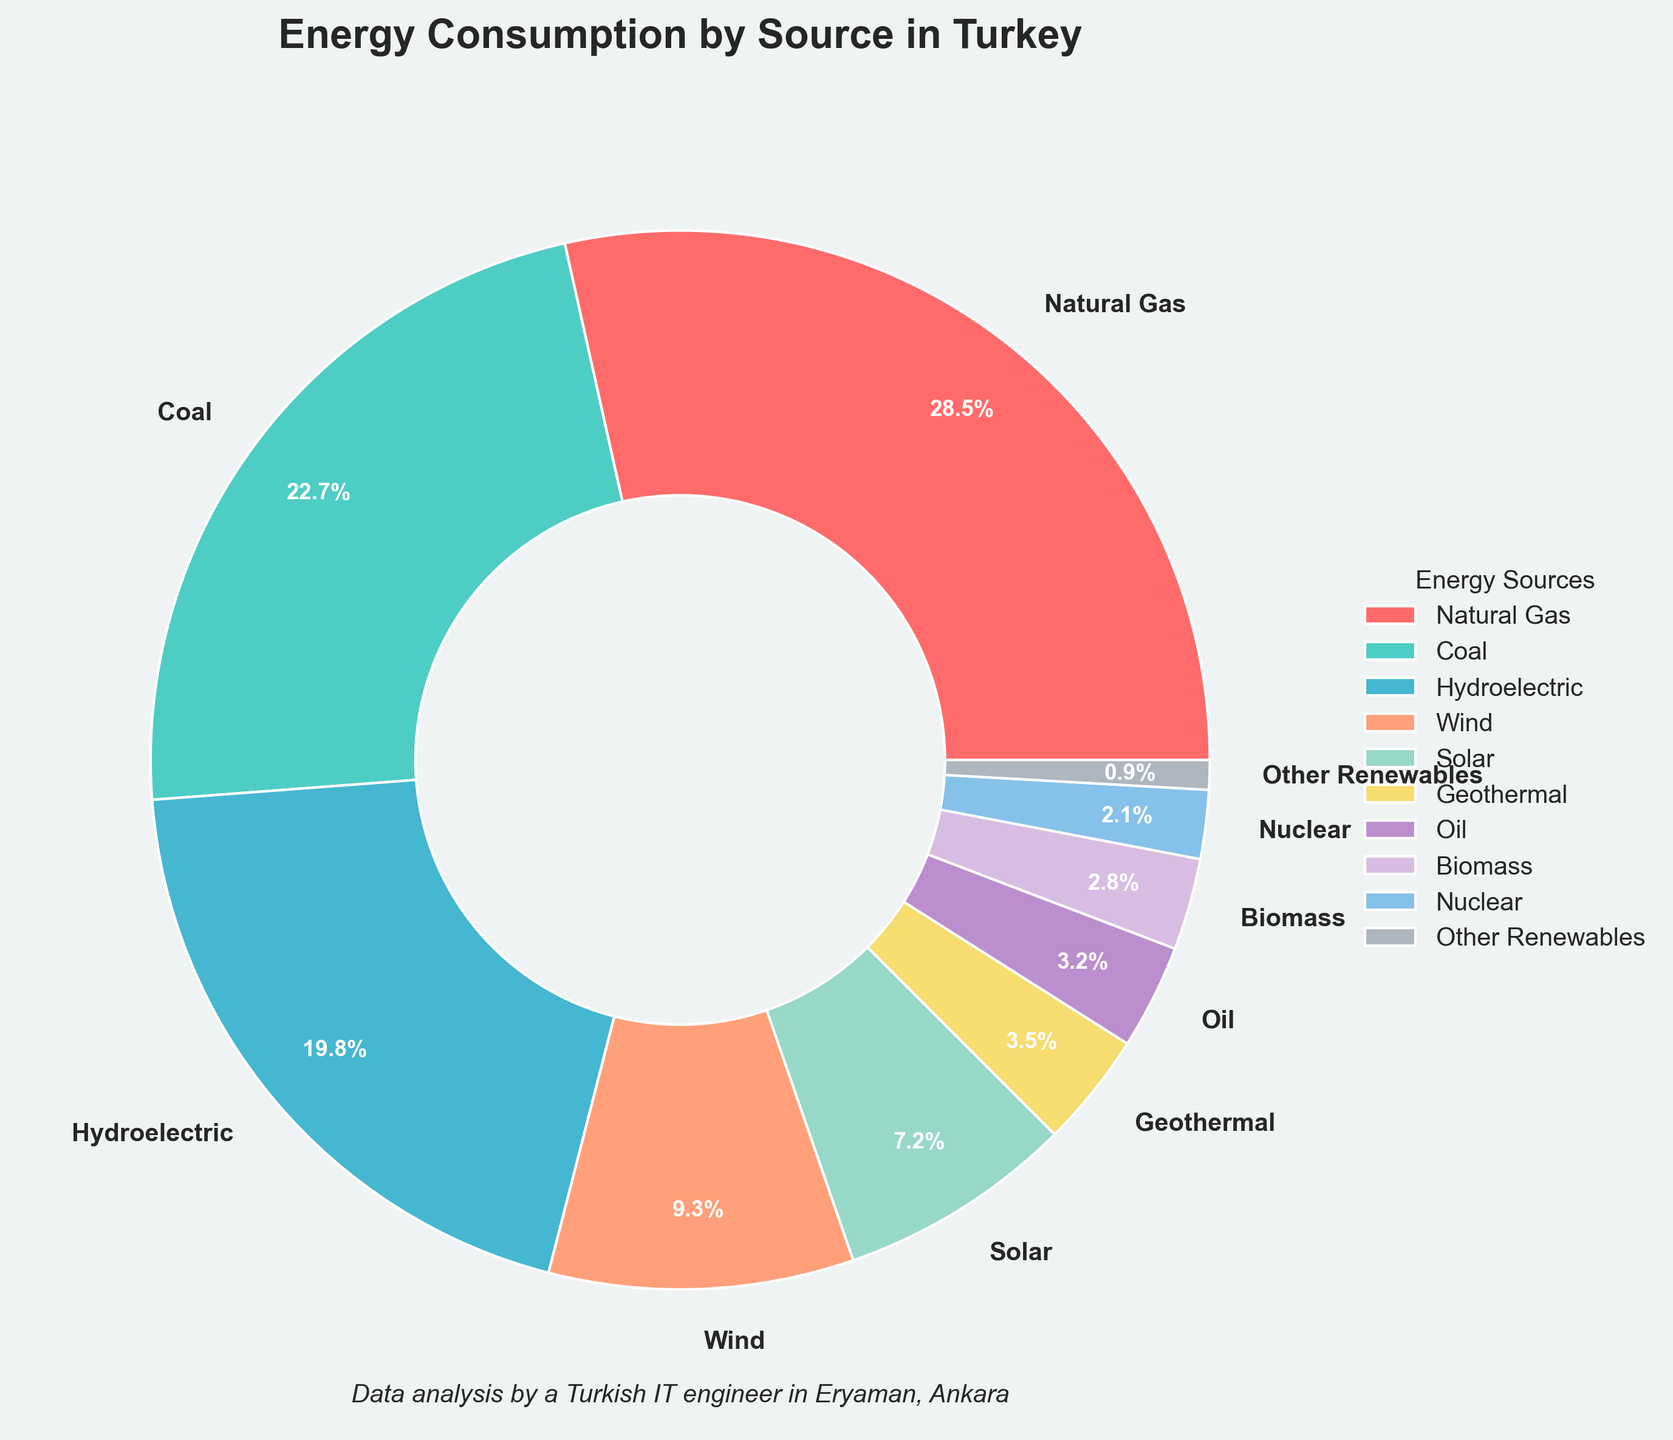What is the energy source with the highest consumption percentage? The pie chart shows the energy sources and their respective consumption percentages. The segment labeled "Natural Gas" has the highest percentage of 28.5%.
Answer: Natural Gas Which two energy sources have the closest consumption percentages, and what are they? By comparing the percentages, "Geothermal" (3.5%) and "Oil" (3.2%) are the closest with a difference of 0.3%.
Answer: Geothermal and Oil What is the total percentage of renewable energy sources (Hydroelectric, Wind, Solar, Geothermal, Biomass, Other Renewables)? Sum the percentages of renewable sources: Hydroelectric (19.8%), Wind (9.3%), Solar (7.2%), Geothermal (3.5%), Biomass (2.8%), Other Renewables (0.9%). The total is 19.8 + 9.3 + 7.2 + 3.5 + 2.8 + 0.9 = 43.5%.
Answer: 43.5% Which energy source contributes the least to energy consumption in Turkey? The smallest segment on the pie chart belongs to "Other Renewables" with 0.9%.
Answer: Other Renewables How much greater is the percentage of Natural Gas consumption compared to Coal consumption? Natural Gas consumption is 28.5% and Coal is 22.7%. Subtract Coal's percentage from Natural Gas’ percentage: 28.5% - 22.7% = 5.8%.
Answer: 5.8% What is the percentage difference between the highest and the lowest contributing energy sources? The highest contributing source is Natural Gas at 28.5% and the lowest is Other Renewables at 0.9%. Subtract the lowest from the highest: 28.5% - 0.9% = 27.6%.
Answer: 27.6% What is the combined percentage of Solar and Wind energy? Add the percentages for Solar (7.2%) and Wind (9.3%): 7.2% + 9.3% = 16.5%.
Answer: 16.5% Between Wind and Biomass, which one is consumed more and by what percentage? Wind has a higher percentage (9.3%) compared to Biomass (2.8%). The difference is 9.3% - 2.8% = 6.5%.
Answer: Wind, by 6.5% What's the percentage of non-renewable energy sources (Natural Gas, Coal, Oil, Nuclear)? Sum the percentages of non-renewable sources: Natural Gas (28.5%), Coal (22.7%), Oil (3.2%), Nuclear (2.1%). The total is 28.5 + 22.7 + 3.2 + 2.1 = 56.5%.
Answer: 56.5% 